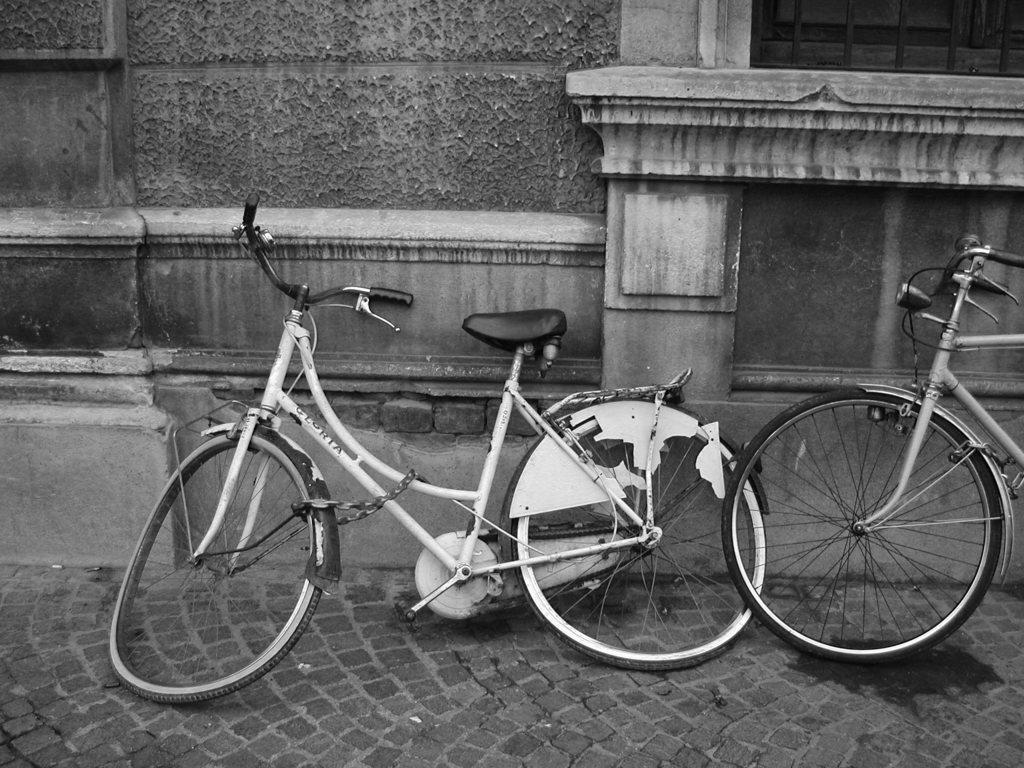What type of vehicles are on the road in the image? There are bicycles on the road in the image. What can be seen in the background of the image? There is a wall visible in the background of the image. What is the rate at which the baseball is being thrown in the image? There is no baseball present in the image, so it is not possible to determine the rate at which it might be thrown. 